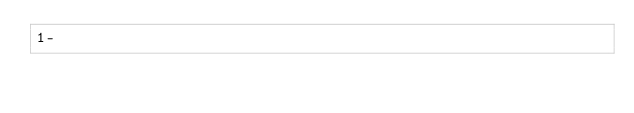<code> <loc_0><loc_0><loc_500><loc_500><_bc_>1-
</code> 